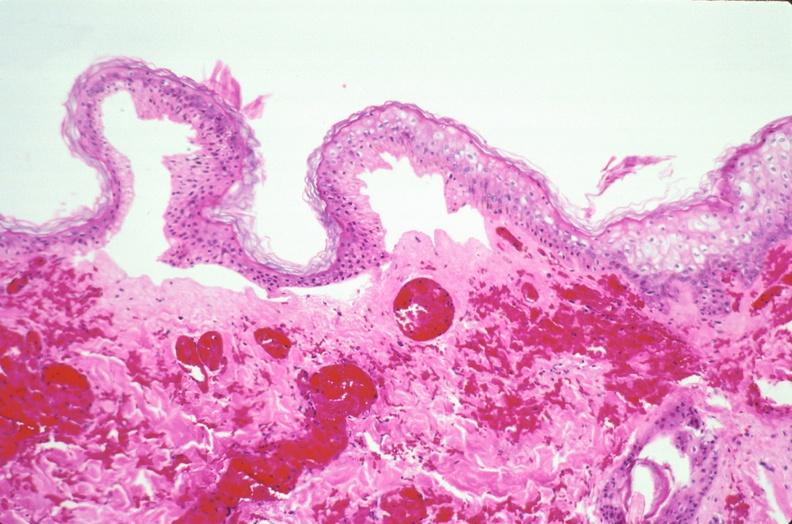does infarction secondary to shock show skin, epidermolysis bullosa?
Answer the question using a single word or phrase. No 